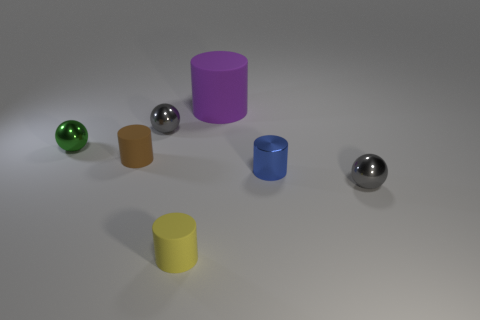Subtract all small brown matte cylinders. How many cylinders are left? 3 Subtract all brown cylinders. How many cylinders are left? 3 Subtract all cylinders. How many objects are left? 3 Subtract 1 spheres. How many spheres are left? 2 Add 3 blue things. How many objects exist? 10 Subtract 1 blue cylinders. How many objects are left? 6 Subtract all brown balls. Subtract all brown blocks. How many balls are left? 3 Subtract all red balls. How many brown cylinders are left? 1 Subtract all large brown rubber objects. Subtract all brown rubber cylinders. How many objects are left? 6 Add 7 gray metallic things. How many gray metallic things are left? 9 